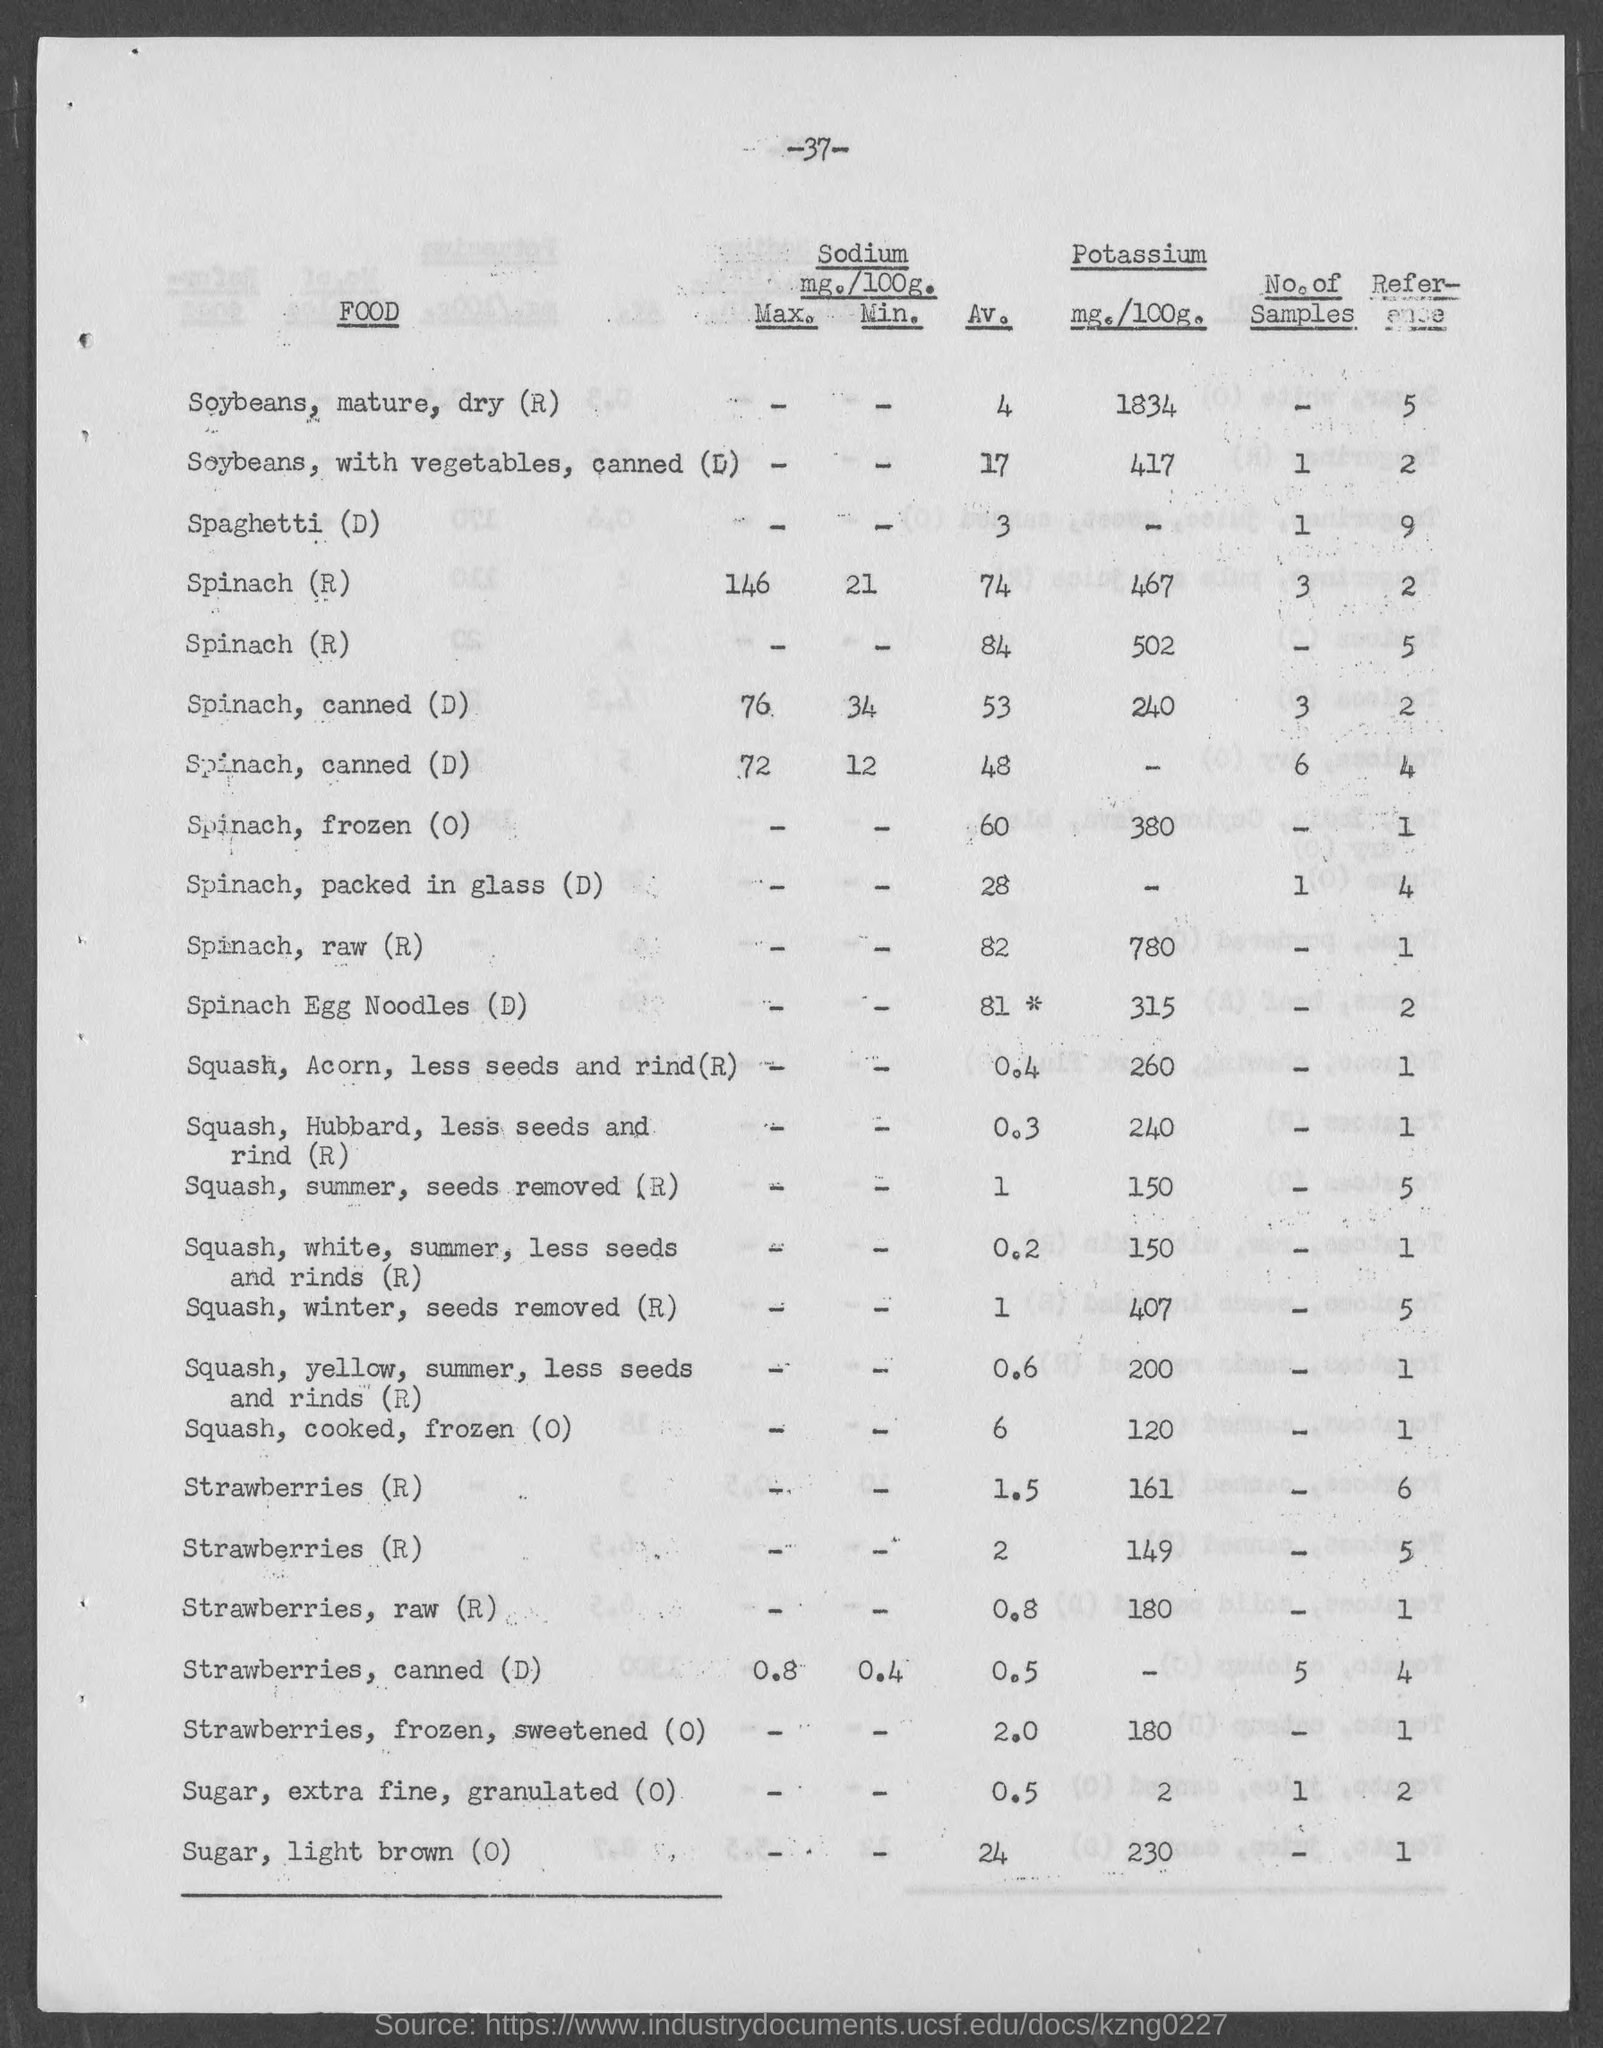what is the amount of Potassium mg./100g. for Squash, Winter, seeds removed ?
 407 